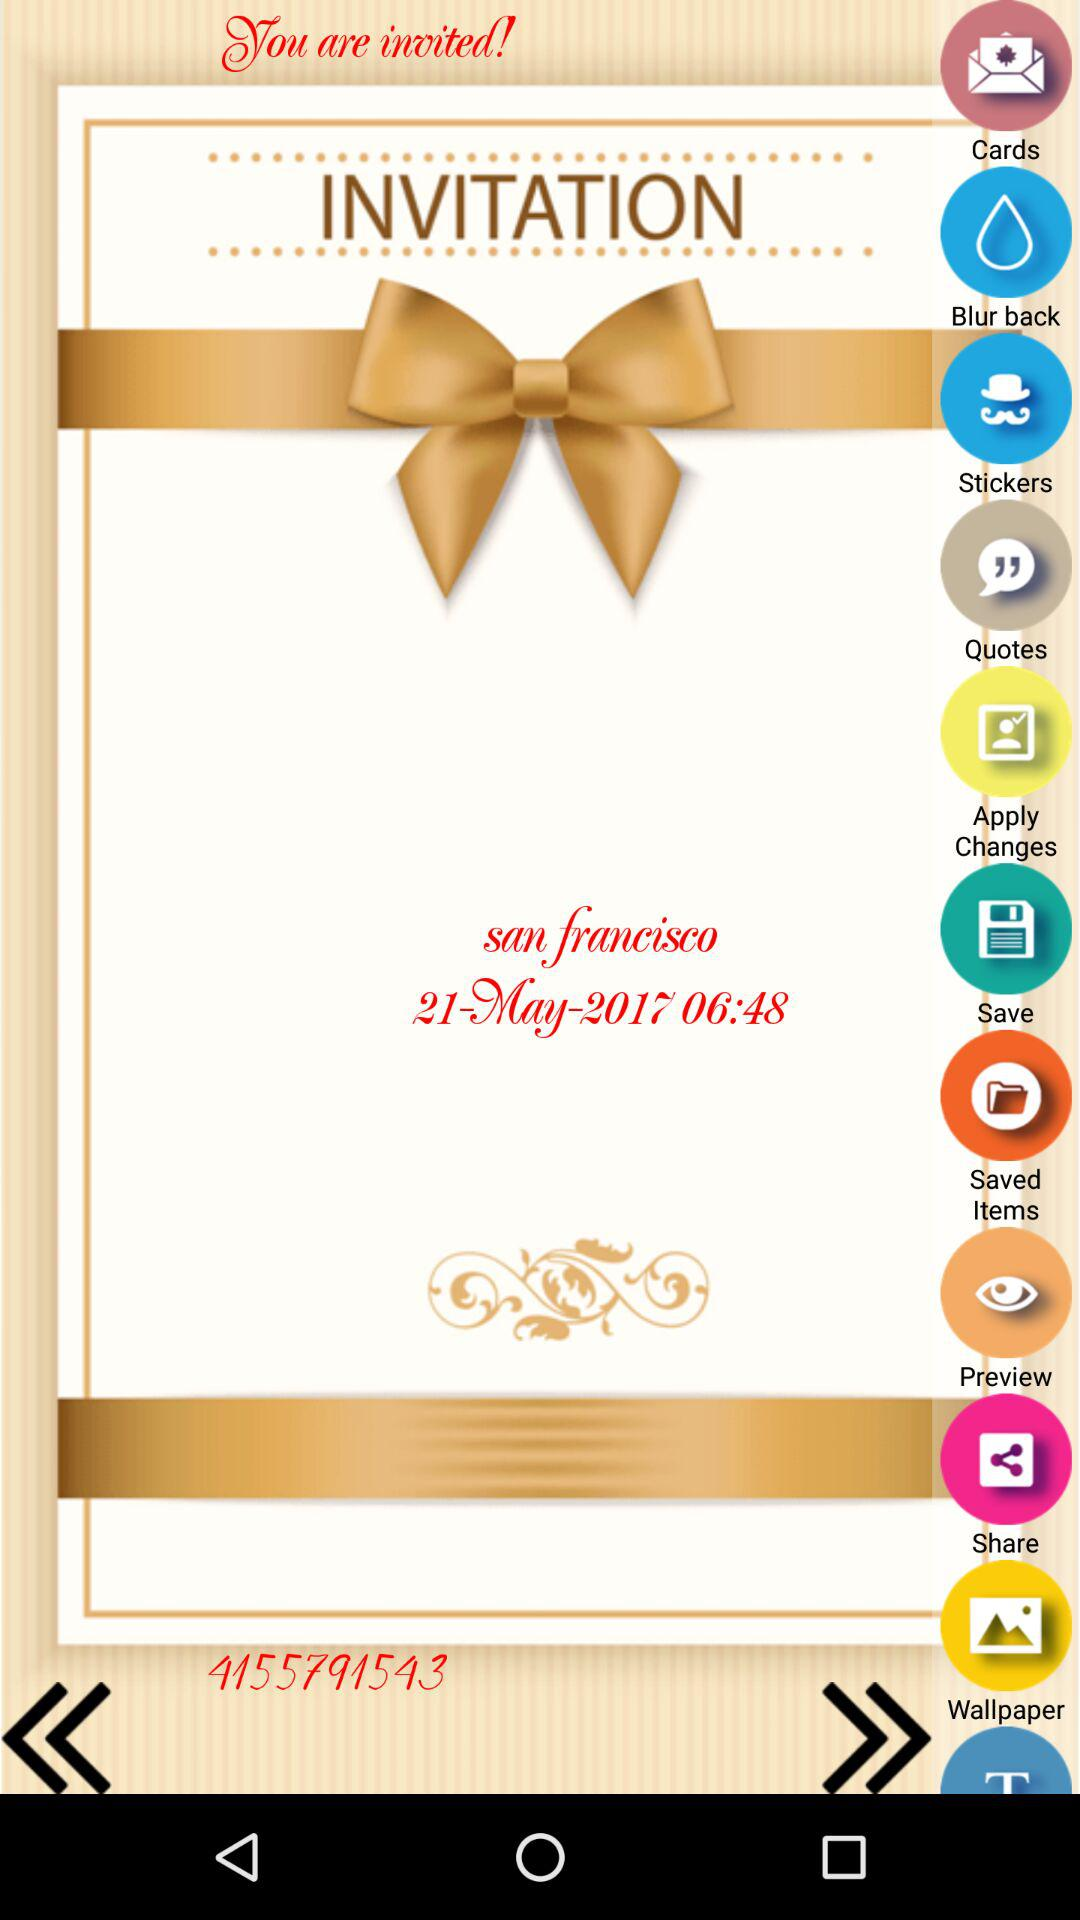What is the number shown on the screen? The number shown is 4155791543. 